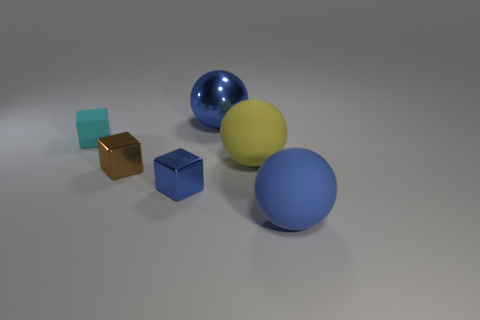How many objects are there in total in the image? There are five objects in the image, consisting of three spheres and two cubes.  Are the cubes the same size? No, the cubes are not the same size; one cube is noticeably smaller than the other. 